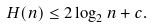Convert formula to latex. <formula><loc_0><loc_0><loc_500><loc_500>H ( n ) \leq 2 \log _ { 2 } n + c .</formula> 